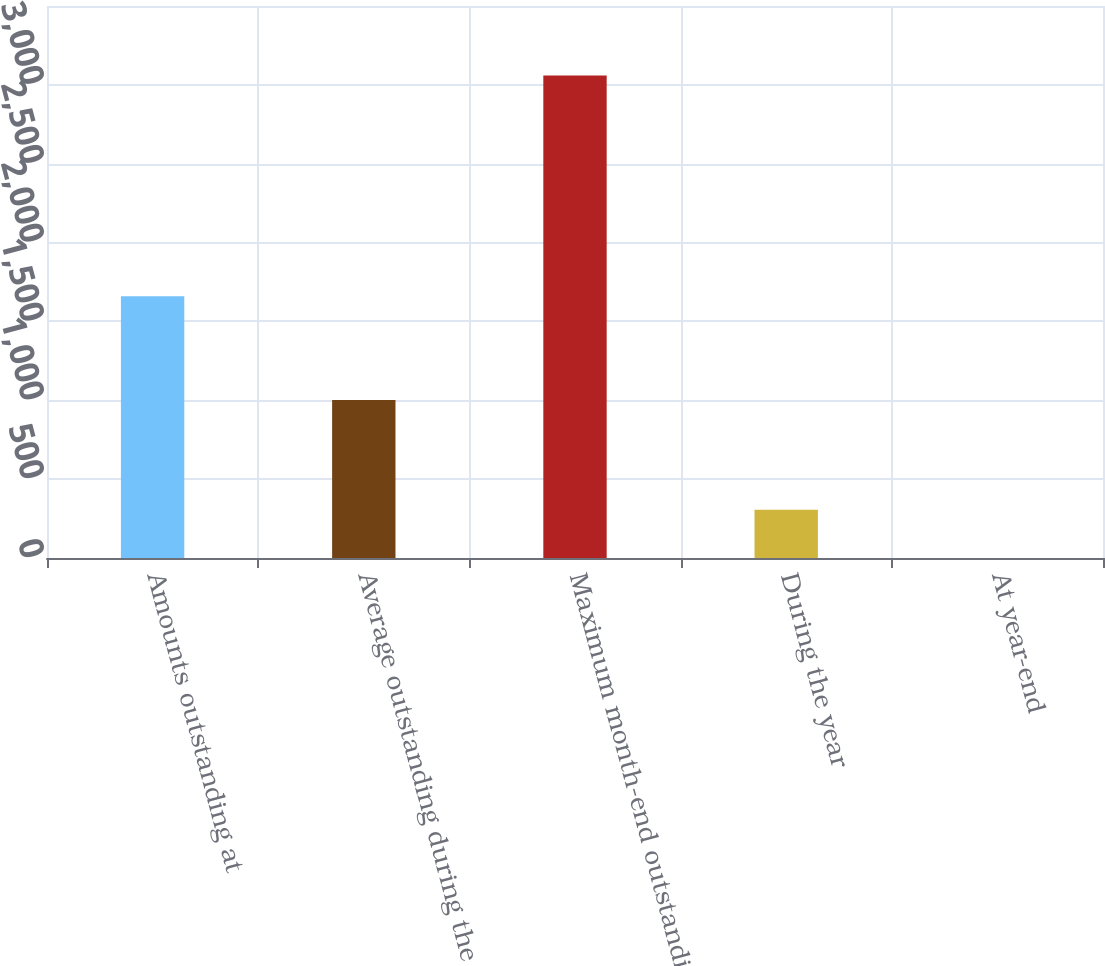Convert chart to OTSL. <chart><loc_0><loc_0><loc_500><loc_500><bar_chart><fcel>Amounts outstanding at<fcel>Average outstanding during the<fcel>Maximum month-end outstanding<fcel>During the year<fcel>At year-end<nl><fcel>1660<fcel>1002<fcel>3060<fcel>306.33<fcel>0.37<nl></chart> 